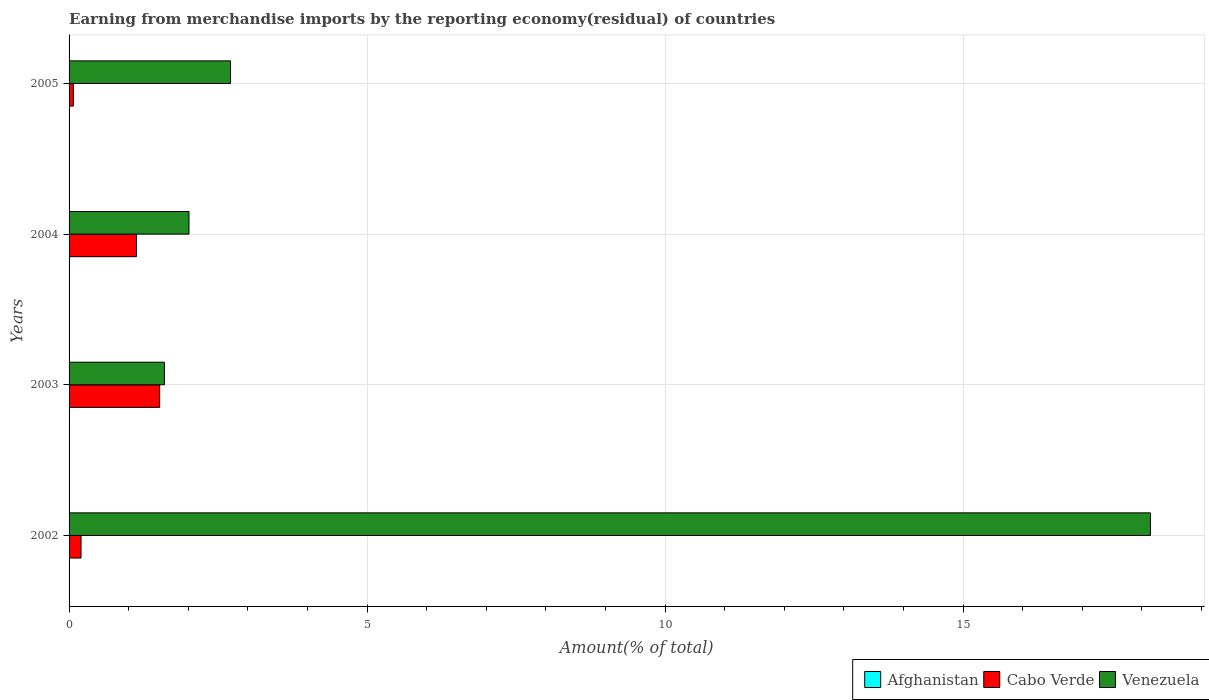How many groups of bars are there?
Your response must be concise. 4. Are the number of bars per tick equal to the number of legend labels?
Your response must be concise. No. How many bars are there on the 1st tick from the top?
Your response must be concise. 3. How many bars are there on the 4th tick from the bottom?
Give a very brief answer. 3. In how many cases, is the number of bars for a given year not equal to the number of legend labels?
Make the answer very short. 1. What is the percentage of amount earned from merchandise imports in Afghanistan in 2005?
Your answer should be compact. 9.024203848127399e-9. Across all years, what is the maximum percentage of amount earned from merchandise imports in Cabo Verde?
Make the answer very short. 1.52. Across all years, what is the minimum percentage of amount earned from merchandise imports in Venezuela?
Ensure brevity in your answer.  1.6. In which year was the percentage of amount earned from merchandise imports in Afghanistan maximum?
Provide a short and direct response. 2004. What is the total percentage of amount earned from merchandise imports in Cabo Verde in the graph?
Ensure brevity in your answer.  2.92. What is the difference between the percentage of amount earned from merchandise imports in Venezuela in 2002 and that in 2004?
Provide a short and direct response. 16.13. What is the difference between the percentage of amount earned from merchandise imports in Afghanistan in 2005 and the percentage of amount earned from merchandise imports in Venezuela in 2002?
Offer a terse response. -18.14. What is the average percentage of amount earned from merchandise imports in Venezuela per year?
Offer a very short reply. 6.12. In the year 2004, what is the difference between the percentage of amount earned from merchandise imports in Cabo Verde and percentage of amount earned from merchandise imports in Venezuela?
Offer a terse response. -0.88. What is the ratio of the percentage of amount earned from merchandise imports in Venezuela in 2003 to that in 2004?
Offer a terse response. 0.8. What is the difference between the highest and the second highest percentage of amount earned from merchandise imports in Venezuela?
Keep it short and to the point. 15.44. What is the difference between the highest and the lowest percentage of amount earned from merchandise imports in Afghanistan?
Make the answer very short. 1.47418343999423e-8. In how many years, is the percentage of amount earned from merchandise imports in Cabo Verde greater than the average percentage of amount earned from merchandise imports in Cabo Verde taken over all years?
Offer a very short reply. 2. Is the sum of the percentage of amount earned from merchandise imports in Venezuela in 2002 and 2003 greater than the maximum percentage of amount earned from merchandise imports in Cabo Verde across all years?
Provide a short and direct response. Yes. How many bars are there?
Your answer should be compact. 11. Are all the bars in the graph horizontal?
Keep it short and to the point. Yes. How many years are there in the graph?
Ensure brevity in your answer.  4. Are the values on the major ticks of X-axis written in scientific E-notation?
Provide a short and direct response. No. Does the graph contain grids?
Offer a terse response. Yes. What is the title of the graph?
Give a very brief answer. Earning from merchandise imports by the reporting economy(residual) of countries. Does "Maldives" appear as one of the legend labels in the graph?
Make the answer very short. No. What is the label or title of the X-axis?
Offer a terse response. Amount(% of total). What is the Amount(% of total) of Cabo Verde in 2002?
Offer a terse response. 0.2. What is the Amount(% of total) of Venezuela in 2002?
Give a very brief answer. 18.14. What is the Amount(% of total) of Afghanistan in 2003?
Offer a terse response. 1.2448027801076e-8. What is the Amount(% of total) in Cabo Verde in 2003?
Provide a short and direct response. 1.52. What is the Amount(% of total) in Venezuela in 2003?
Your answer should be compact. 1.6. What is the Amount(% of total) in Afghanistan in 2004?
Your answer should be compact. 1.47418343999423e-8. What is the Amount(% of total) of Cabo Verde in 2004?
Ensure brevity in your answer.  1.13. What is the Amount(% of total) in Venezuela in 2004?
Give a very brief answer. 2.01. What is the Amount(% of total) of Afghanistan in 2005?
Provide a short and direct response. 9.024203848127399e-9. What is the Amount(% of total) in Cabo Verde in 2005?
Provide a short and direct response. 0.07. What is the Amount(% of total) of Venezuela in 2005?
Your answer should be very brief. 2.71. Across all years, what is the maximum Amount(% of total) in Afghanistan?
Give a very brief answer. 1.47418343999423e-8. Across all years, what is the maximum Amount(% of total) in Cabo Verde?
Provide a short and direct response. 1.52. Across all years, what is the maximum Amount(% of total) of Venezuela?
Provide a short and direct response. 18.14. Across all years, what is the minimum Amount(% of total) in Afghanistan?
Give a very brief answer. 0. Across all years, what is the minimum Amount(% of total) in Cabo Verde?
Offer a very short reply. 0.07. Across all years, what is the minimum Amount(% of total) in Venezuela?
Provide a succinct answer. 1.6. What is the total Amount(% of total) in Cabo Verde in the graph?
Your answer should be very brief. 2.92. What is the total Amount(% of total) in Venezuela in the graph?
Your answer should be compact. 24.47. What is the difference between the Amount(% of total) in Cabo Verde in 2002 and that in 2003?
Make the answer very short. -1.32. What is the difference between the Amount(% of total) of Venezuela in 2002 and that in 2003?
Your answer should be compact. 16.54. What is the difference between the Amount(% of total) of Cabo Verde in 2002 and that in 2004?
Your answer should be compact. -0.93. What is the difference between the Amount(% of total) of Venezuela in 2002 and that in 2004?
Ensure brevity in your answer.  16.13. What is the difference between the Amount(% of total) of Cabo Verde in 2002 and that in 2005?
Provide a succinct answer. 0.13. What is the difference between the Amount(% of total) in Venezuela in 2002 and that in 2005?
Provide a short and direct response. 15.44. What is the difference between the Amount(% of total) in Afghanistan in 2003 and that in 2004?
Make the answer very short. -0. What is the difference between the Amount(% of total) of Cabo Verde in 2003 and that in 2004?
Offer a very short reply. 0.39. What is the difference between the Amount(% of total) in Venezuela in 2003 and that in 2004?
Your answer should be very brief. -0.41. What is the difference between the Amount(% of total) of Cabo Verde in 2003 and that in 2005?
Offer a terse response. 1.45. What is the difference between the Amount(% of total) of Venezuela in 2003 and that in 2005?
Your response must be concise. -1.11. What is the difference between the Amount(% of total) of Cabo Verde in 2004 and that in 2005?
Your answer should be very brief. 1.06. What is the difference between the Amount(% of total) in Venezuela in 2004 and that in 2005?
Ensure brevity in your answer.  -0.7. What is the difference between the Amount(% of total) of Cabo Verde in 2002 and the Amount(% of total) of Venezuela in 2003?
Make the answer very short. -1.4. What is the difference between the Amount(% of total) of Cabo Verde in 2002 and the Amount(% of total) of Venezuela in 2004?
Offer a terse response. -1.81. What is the difference between the Amount(% of total) of Cabo Verde in 2002 and the Amount(% of total) of Venezuela in 2005?
Provide a succinct answer. -2.51. What is the difference between the Amount(% of total) of Afghanistan in 2003 and the Amount(% of total) of Cabo Verde in 2004?
Your answer should be very brief. -1.13. What is the difference between the Amount(% of total) in Afghanistan in 2003 and the Amount(% of total) in Venezuela in 2004?
Give a very brief answer. -2.01. What is the difference between the Amount(% of total) of Cabo Verde in 2003 and the Amount(% of total) of Venezuela in 2004?
Your response must be concise. -0.49. What is the difference between the Amount(% of total) of Afghanistan in 2003 and the Amount(% of total) of Cabo Verde in 2005?
Ensure brevity in your answer.  -0.07. What is the difference between the Amount(% of total) in Afghanistan in 2003 and the Amount(% of total) in Venezuela in 2005?
Your answer should be very brief. -2.71. What is the difference between the Amount(% of total) in Cabo Verde in 2003 and the Amount(% of total) in Venezuela in 2005?
Offer a terse response. -1.19. What is the difference between the Amount(% of total) of Afghanistan in 2004 and the Amount(% of total) of Cabo Verde in 2005?
Your response must be concise. -0.07. What is the difference between the Amount(% of total) of Afghanistan in 2004 and the Amount(% of total) of Venezuela in 2005?
Provide a succinct answer. -2.71. What is the difference between the Amount(% of total) in Cabo Verde in 2004 and the Amount(% of total) in Venezuela in 2005?
Give a very brief answer. -1.58. What is the average Amount(% of total) in Cabo Verde per year?
Keep it short and to the point. 0.73. What is the average Amount(% of total) in Venezuela per year?
Provide a short and direct response. 6.12. In the year 2002, what is the difference between the Amount(% of total) of Cabo Verde and Amount(% of total) of Venezuela?
Give a very brief answer. -17.94. In the year 2003, what is the difference between the Amount(% of total) in Afghanistan and Amount(% of total) in Cabo Verde?
Your response must be concise. -1.52. In the year 2003, what is the difference between the Amount(% of total) of Afghanistan and Amount(% of total) of Venezuela?
Offer a terse response. -1.6. In the year 2003, what is the difference between the Amount(% of total) of Cabo Verde and Amount(% of total) of Venezuela?
Keep it short and to the point. -0.08. In the year 2004, what is the difference between the Amount(% of total) in Afghanistan and Amount(% of total) in Cabo Verde?
Your response must be concise. -1.13. In the year 2004, what is the difference between the Amount(% of total) in Afghanistan and Amount(% of total) in Venezuela?
Ensure brevity in your answer.  -2.01. In the year 2004, what is the difference between the Amount(% of total) of Cabo Verde and Amount(% of total) of Venezuela?
Ensure brevity in your answer.  -0.88. In the year 2005, what is the difference between the Amount(% of total) of Afghanistan and Amount(% of total) of Cabo Verde?
Keep it short and to the point. -0.07. In the year 2005, what is the difference between the Amount(% of total) of Afghanistan and Amount(% of total) of Venezuela?
Your answer should be compact. -2.71. In the year 2005, what is the difference between the Amount(% of total) in Cabo Verde and Amount(% of total) in Venezuela?
Make the answer very short. -2.64. What is the ratio of the Amount(% of total) in Cabo Verde in 2002 to that in 2003?
Give a very brief answer. 0.13. What is the ratio of the Amount(% of total) in Venezuela in 2002 to that in 2003?
Ensure brevity in your answer.  11.34. What is the ratio of the Amount(% of total) of Cabo Verde in 2002 to that in 2004?
Ensure brevity in your answer.  0.18. What is the ratio of the Amount(% of total) of Venezuela in 2002 to that in 2004?
Provide a short and direct response. 9.02. What is the ratio of the Amount(% of total) of Cabo Verde in 2002 to that in 2005?
Provide a succinct answer. 2.78. What is the ratio of the Amount(% of total) of Venezuela in 2002 to that in 2005?
Ensure brevity in your answer.  6.7. What is the ratio of the Amount(% of total) of Afghanistan in 2003 to that in 2004?
Ensure brevity in your answer.  0.84. What is the ratio of the Amount(% of total) in Cabo Verde in 2003 to that in 2004?
Your answer should be very brief. 1.34. What is the ratio of the Amount(% of total) of Venezuela in 2003 to that in 2004?
Your answer should be very brief. 0.8. What is the ratio of the Amount(% of total) of Afghanistan in 2003 to that in 2005?
Make the answer very short. 1.38. What is the ratio of the Amount(% of total) of Cabo Verde in 2003 to that in 2005?
Keep it short and to the point. 21.05. What is the ratio of the Amount(% of total) of Venezuela in 2003 to that in 2005?
Provide a short and direct response. 0.59. What is the ratio of the Amount(% of total) in Afghanistan in 2004 to that in 2005?
Offer a very short reply. 1.63. What is the ratio of the Amount(% of total) of Cabo Verde in 2004 to that in 2005?
Provide a succinct answer. 15.66. What is the ratio of the Amount(% of total) in Venezuela in 2004 to that in 2005?
Your answer should be very brief. 0.74. What is the difference between the highest and the second highest Amount(% of total) in Cabo Verde?
Your answer should be compact. 0.39. What is the difference between the highest and the second highest Amount(% of total) of Venezuela?
Your response must be concise. 15.44. What is the difference between the highest and the lowest Amount(% of total) in Afghanistan?
Your response must be concise. 0. What is the difference between the highest and the lowest Amount(% of total) in Cabo Verde?
Keep it short and to the point. 1.45. What is the difference between the highest and the lowest Amount(% of total) in Venezuela?
Your response must be concise. 16.54. 